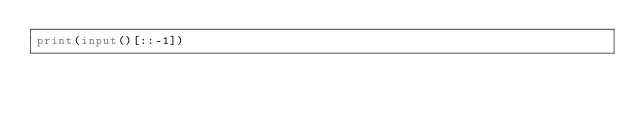<code> <loc_0><loc_0><loc_500><loc_500><_Python_>print(input()[::-1])
</code> 